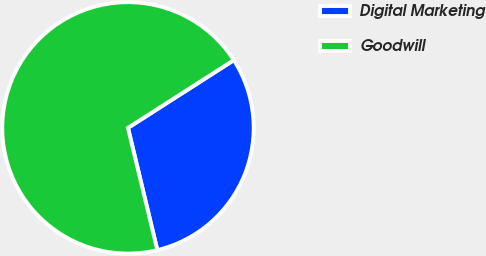Convert chart to OTSL. <chart><loc_0><loc_0><loc_500><loc_500><pie_chart><fcel>Digital Marketing<fcel>Goodwill<nl><fcel>30.31%<fcel>69.69%<nl></chart> 